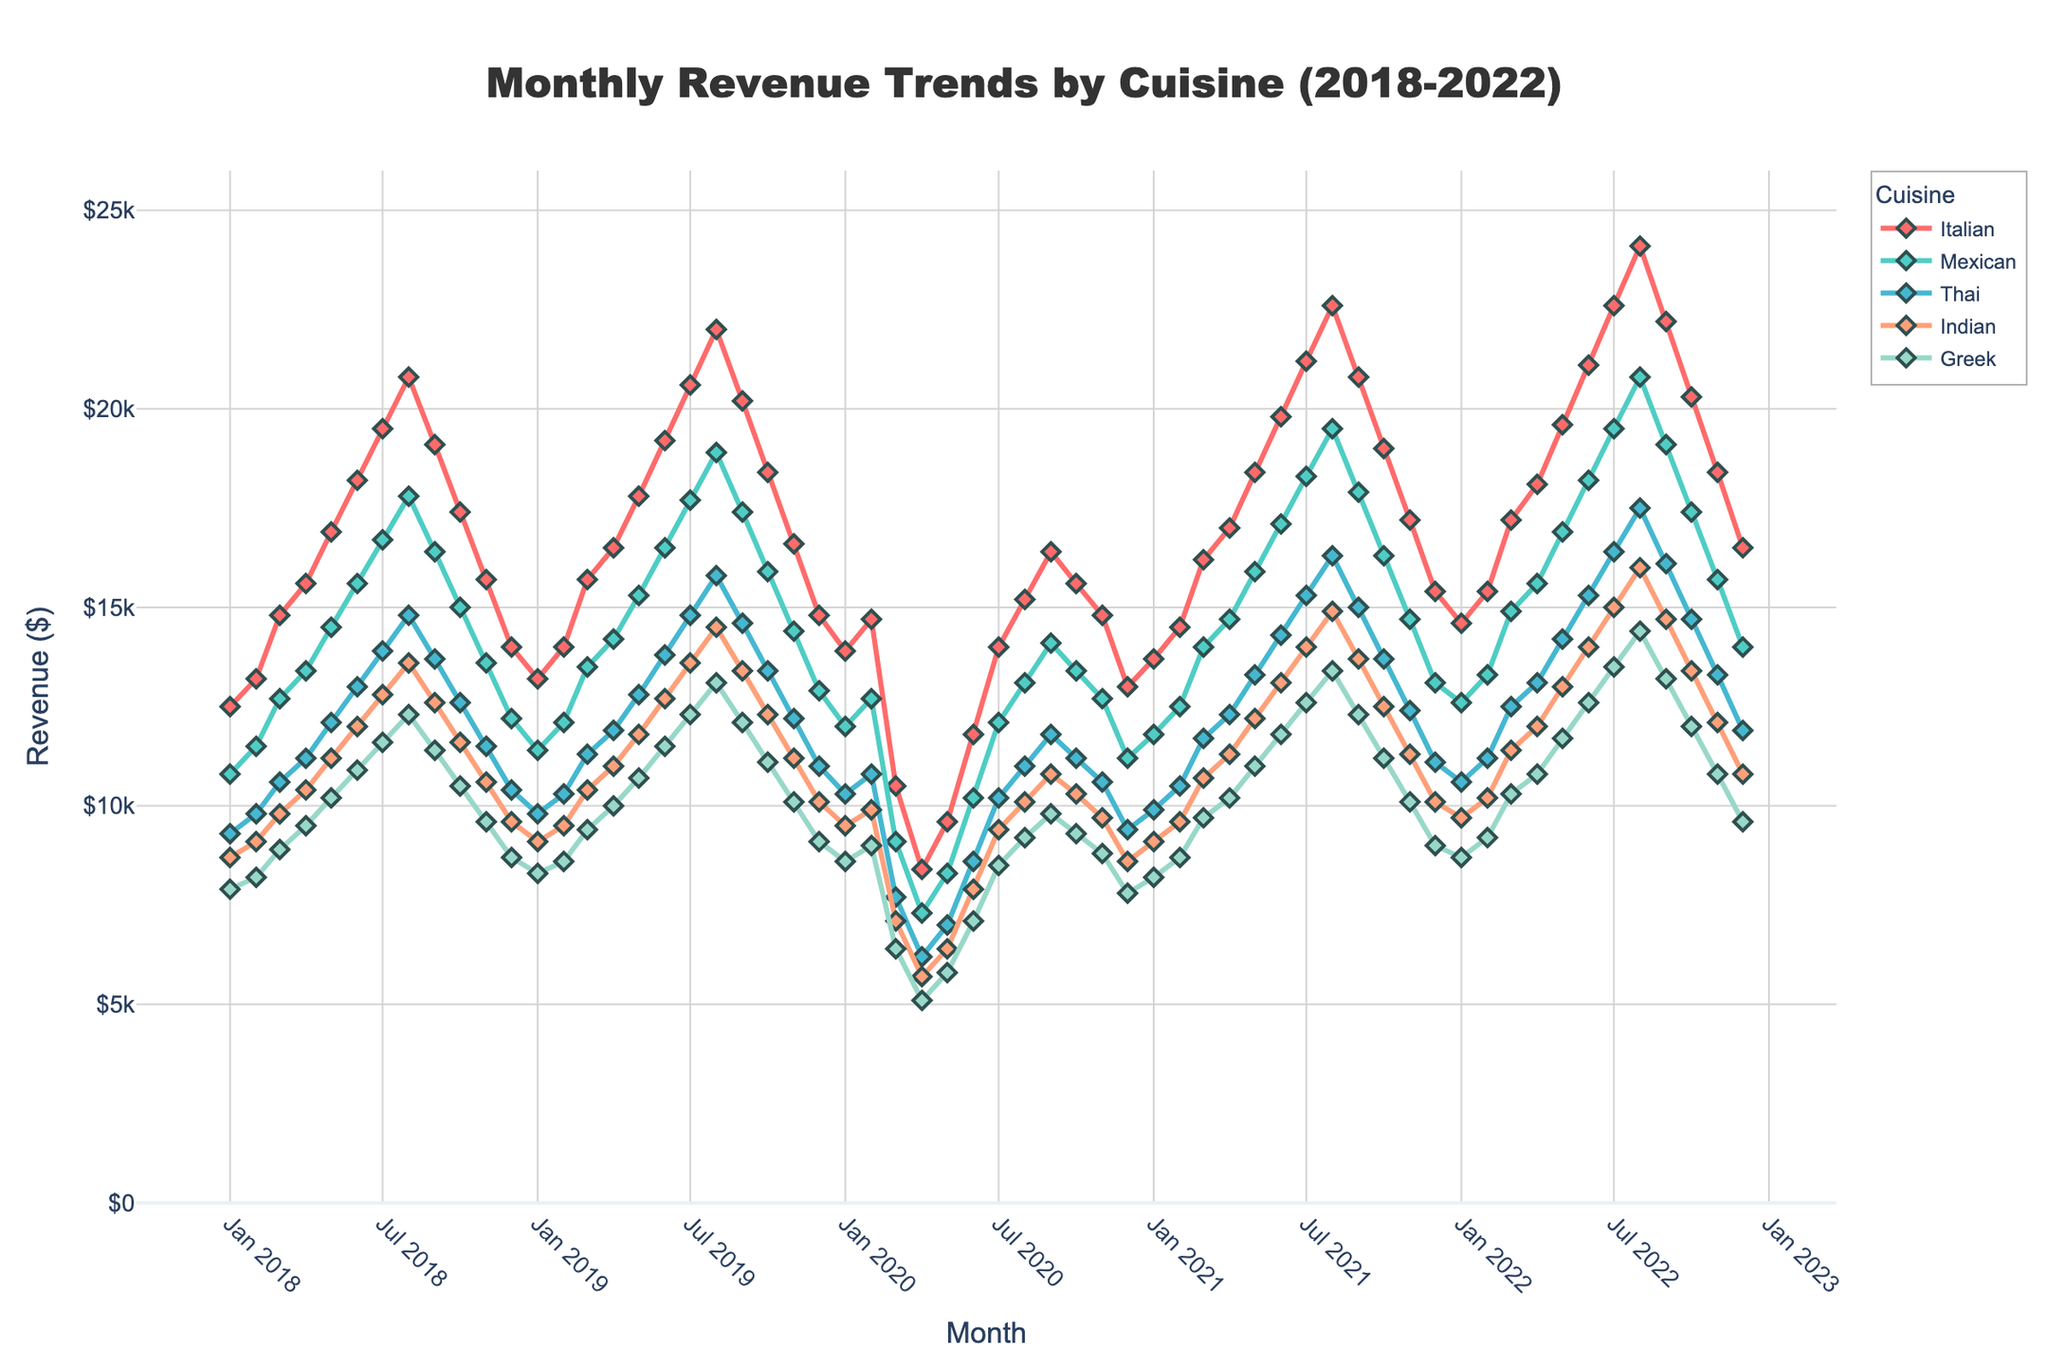What was the revenue for Italian cuisine in March 2019? To find the revenue for Italian cuisine in March 2019, look for the corresponding data point on the Italian line in the figure for that month.
Answer: $15,700 Which cuisine had the highest revenue in August 2022? Look at the data points for August 2022 across all cuisines and identify which line reaches the highest point.
Answer: Italian What is the average revenue for Greek cuisine from January 2018 to December 2018? Sum the monthly revenues for Greek cuisine from January 2018 to December 2018 and divide by 12 (the number of months). (7900 + 8200 + 8900 + 9500 + 10200 + 10900 + 11600 + 12300 + 11400 + 10500 + 9600 + 8700) / 12.
Answer: $9,850 How does the trend for Mexican cuisine in 2020 compare to 2019? Compare the Mexican cuisine revenue line from January to December in both years, noting any rises, falls, or patterns in the two periods.
Answer: 2020 experienced a significant drop in revenue around March-April, then steady growth, unlike 2019 which showed consistent growth throughout the year Which month saw the lowest revenue for Thai cuisine across the entire period? Identify the lowest point on the Thai cuisine line across all the months.
Answer: April 2020 Has the revenue for Indian cuisine consistently increased or decreased each year from 2018 to 2022? Track the annual peaks or valleys of the Indian cuisine line and compare year-over-year to determine the trend.
Answer: It shows consistent growth from 2018 to early 2020, a decrease mid-2020, then a recovery and growth from 2021 to 2022 Which cuisine experienced the most volatility (largest swings in revenue) between 2019 and 2021? Compare the peaks and troughs of each cuisine's revenue lines between 2019 and 2021 to see which had the largest variations.
Answer: Thai What was the difference in revenue between Italian and Greek cuisine in July 2021? Subtract the revenue for Greek cuisine in July 2021 from the revenue for Italian cuisine in the same month. $21,200 - $12,600.
Answer: $8,600 What was the total revenue for Mexican cuisine in 2020? Sum up the monthly revenues for Mexican cuisine from January 2020 to December 2020. 12000 + 12700 + 9100 + 7300 + 8300 + 10200 + 12100 + 13100 + 14100 + 13400 + 12700 + 11200.
Answer: $139,800 Did any cuisine surpass the $20,000 monthly revenue mark before 2019? If so, which? Check the figure for any data point for the cuisines before 2019 that go above the $20,000 revenue line.
Answer: No 